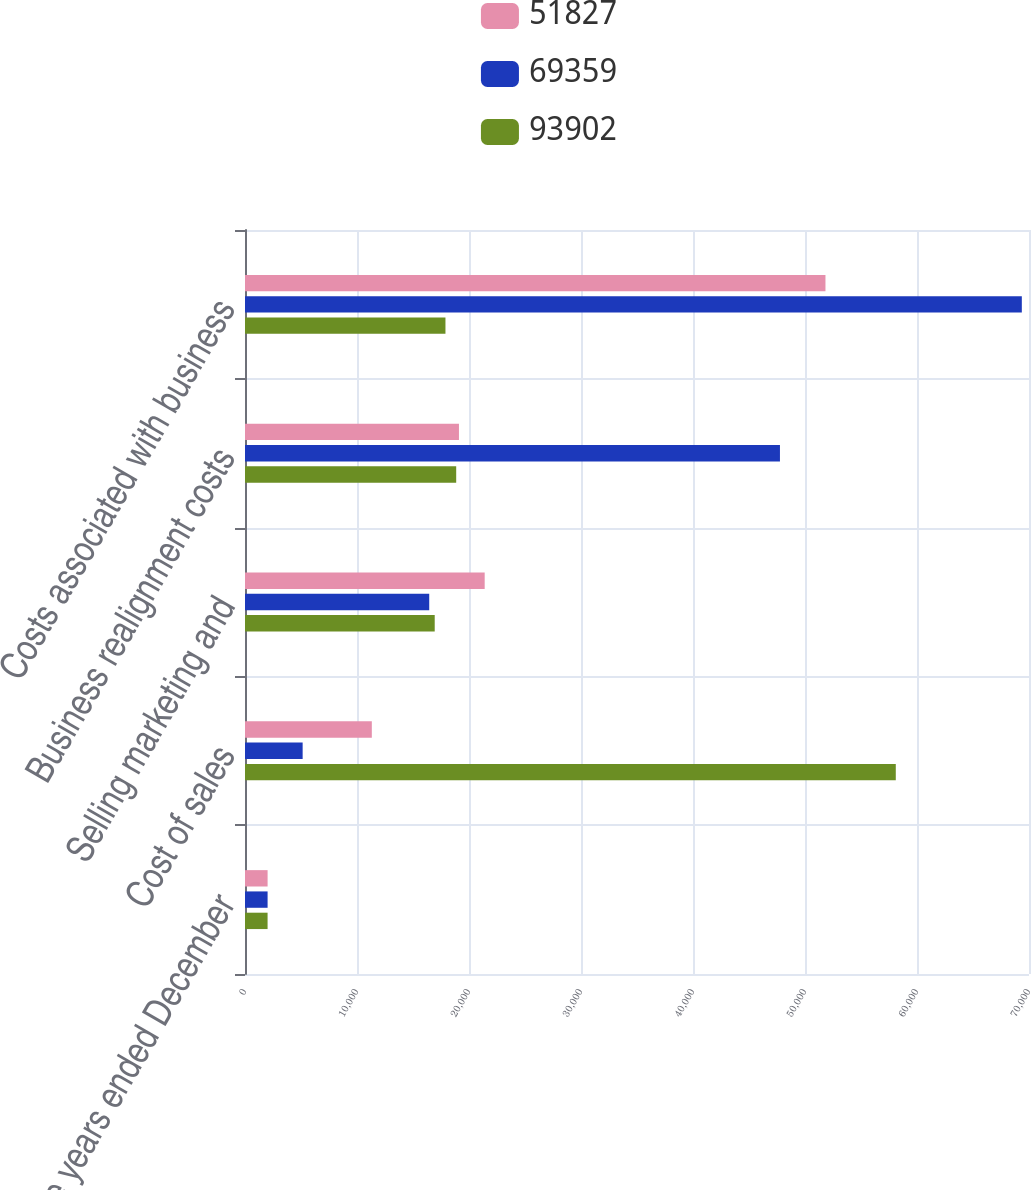Convert chart. <chart><loc_0><loc_0><loc_500><loc_500><stacked_bar_chart><ecel><fcel>For the years ended December<fcel>Cost of sales<fcel>Selling marketing and<fcel>Business realignment costs<fcel>Costs associated with business<nl><fcel>51827<fcel>2018<fcel>11323<fcel>21401<fcel>19103<fcel>51827<nl><fcel>69359<fcel>2017<fcel>5147<fcel>16449<fcel>47763<fcel>69359<nl><fcel>93902<fcel>2016<fcel>58106<fcel>16939<fcel>18857<fcel>17898<nl></chart> 